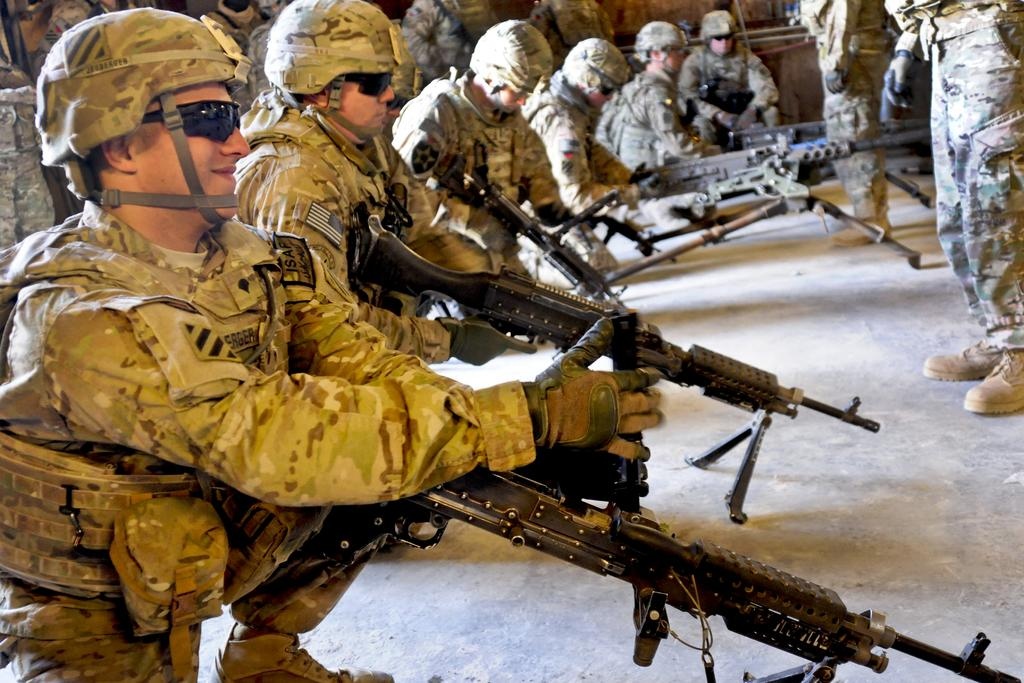What can be seen in the image? There is a group of people in the image. What are the people wearing? The people are wearing military uniforms. Are there any objects being held by the people? Yes, some people are holding weapons. What type of protective gear is being worn by some people? Some people are wearing goggles. What flavor of rabbits can be seen in the image? There are no rabbits present in the image, so it is not possible to determine their flavor. 